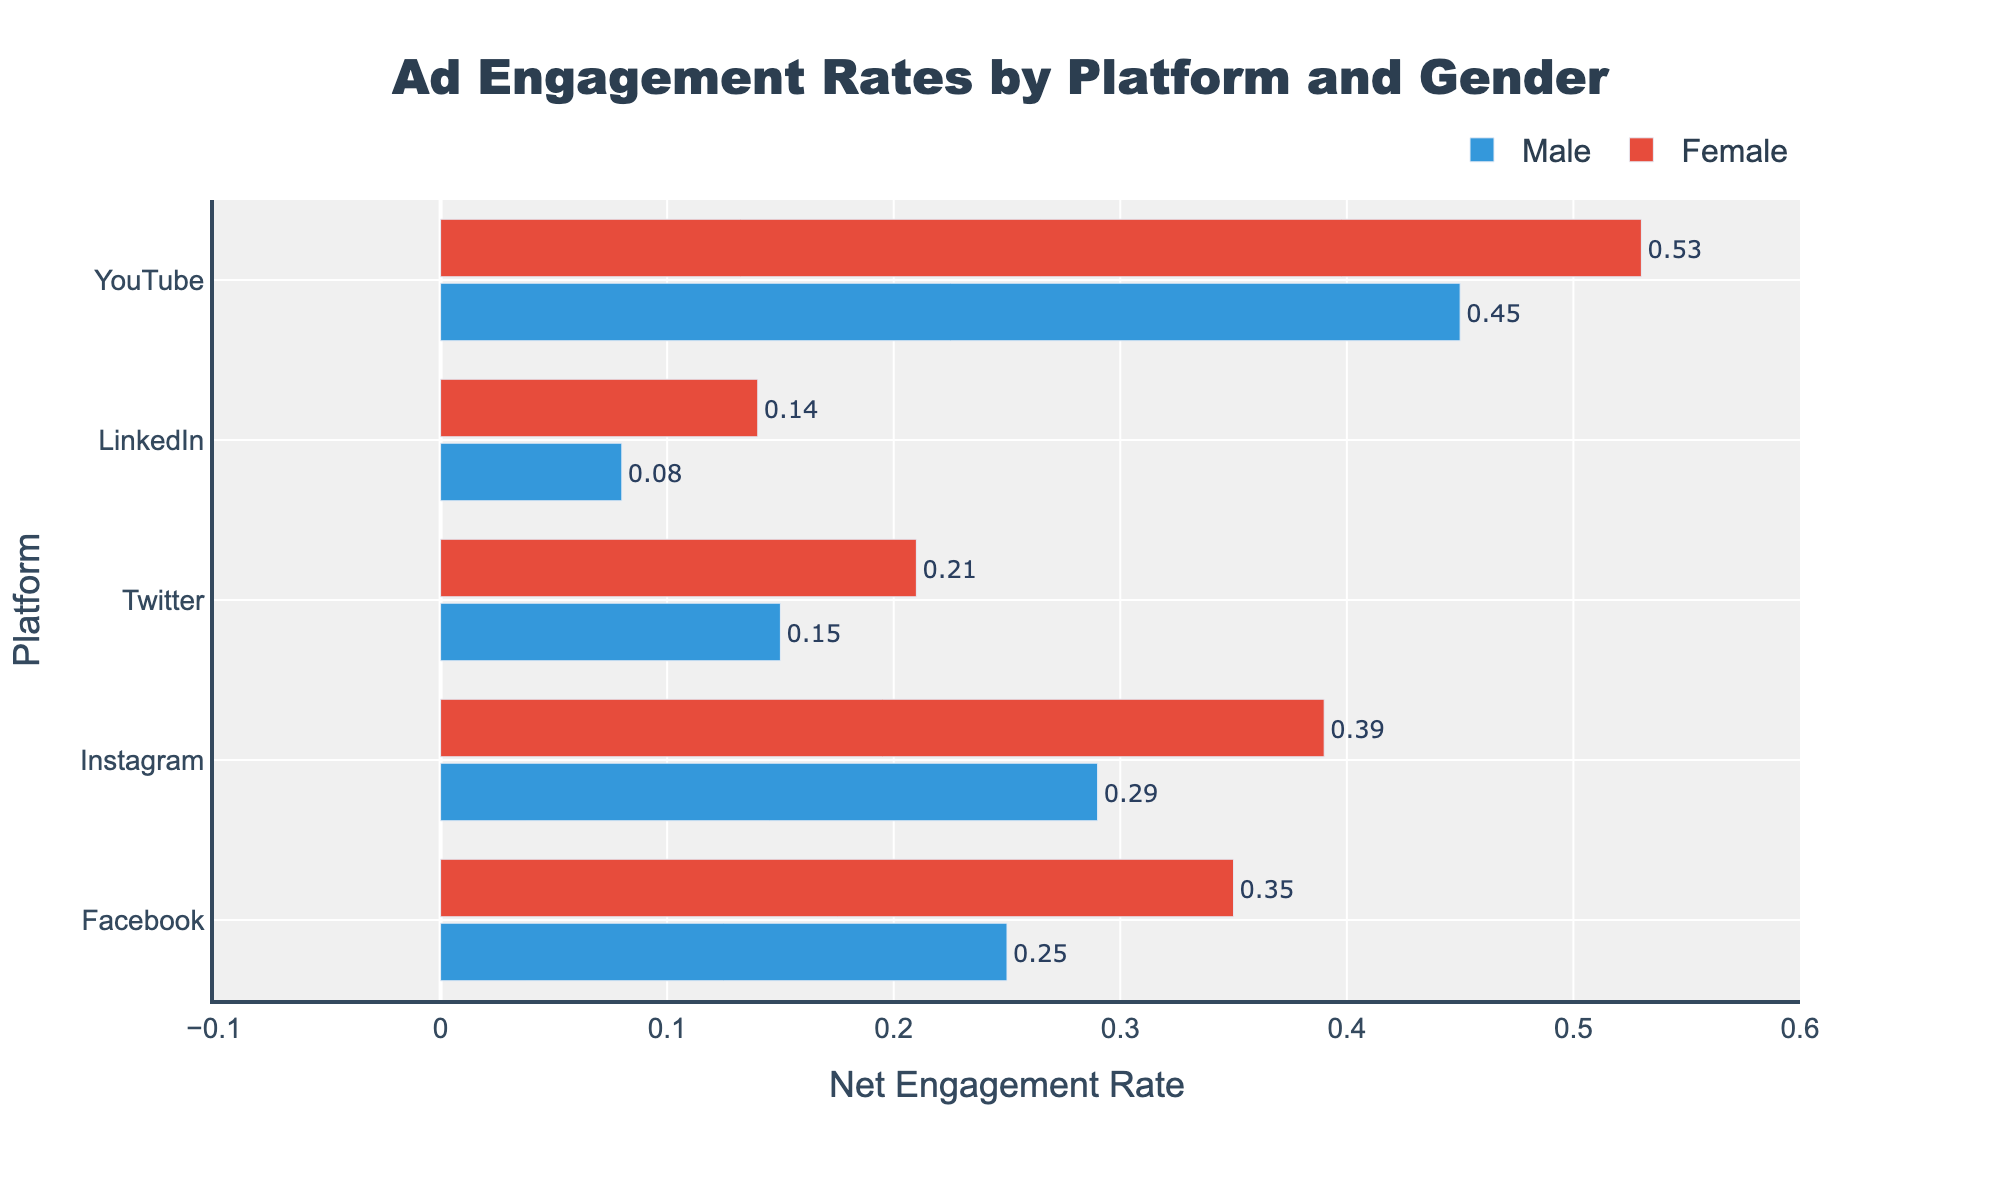What is the net engagement rate for females on Facebook? To find the net engagement rate for females on Facebook, subtract the negative engagement rate (0.15) from the positive engagement rate (0.50). So, 0.50 - 0.15 equals 0.35.
Answer: 0.35 Which platform has the highest net engagement rate for males? The net engagement rates for males are: Facebook (0.25), Instagram (0.29), Twitter (0.15), LinkedIn (0.08), and YouTube (0.45). The highest value is for YouTube, which is 0.45.
Answer: YouTube How does the net engagement rate for males on Twitter compare to females on the same platform? The net engagement rate for males on Twitter is calculated by 0.40 (positive) - 0.25 (negative) = 0.15. For females on Twitter, it is 0.43 - 0.22 = 0.21. Comparing these, females have a higher net engagement rate.
Answer: Females have a higher net engagement rate What is the combined net engagement rate for females on Facebook and YouTube? The net engagement rate for females on Facebook is 0.35 and on YouTube is 0.53. Adding these together, 0.35 + 0.53 equals 0.88.
Answer: 0.88 Compare the net engagement rates of males and females on Instagram. Who has a higher rate? For males on Instagram, the net engagement rate is 0.47 - 0.18 = 0.29. For females, it is 0.52 - 0.13 = 0.39. Females have a higher net engagement rate on Instagram.
Answer: Females Which platform shows the lowest net engagement rate for females? The net engagement rates for females are: Facebook (0.35), Instagram (0.39), Twitter (0.21), LinkedIn (0.14), and YouTube (0.53). The lowest value is for LinkedIn, which is 0.14.
Answer: LinkedIn What is the difference in net engagement rates between males and females on LinkedIn? The net engagement rate for males on LinkedIn is 0.38 - 0.30 = 0.08. For females, it is 0.42 - 0.28 = 0.14. The difference is 0.14 - 0.08 which equals 0.06.
Answer: 0.06 